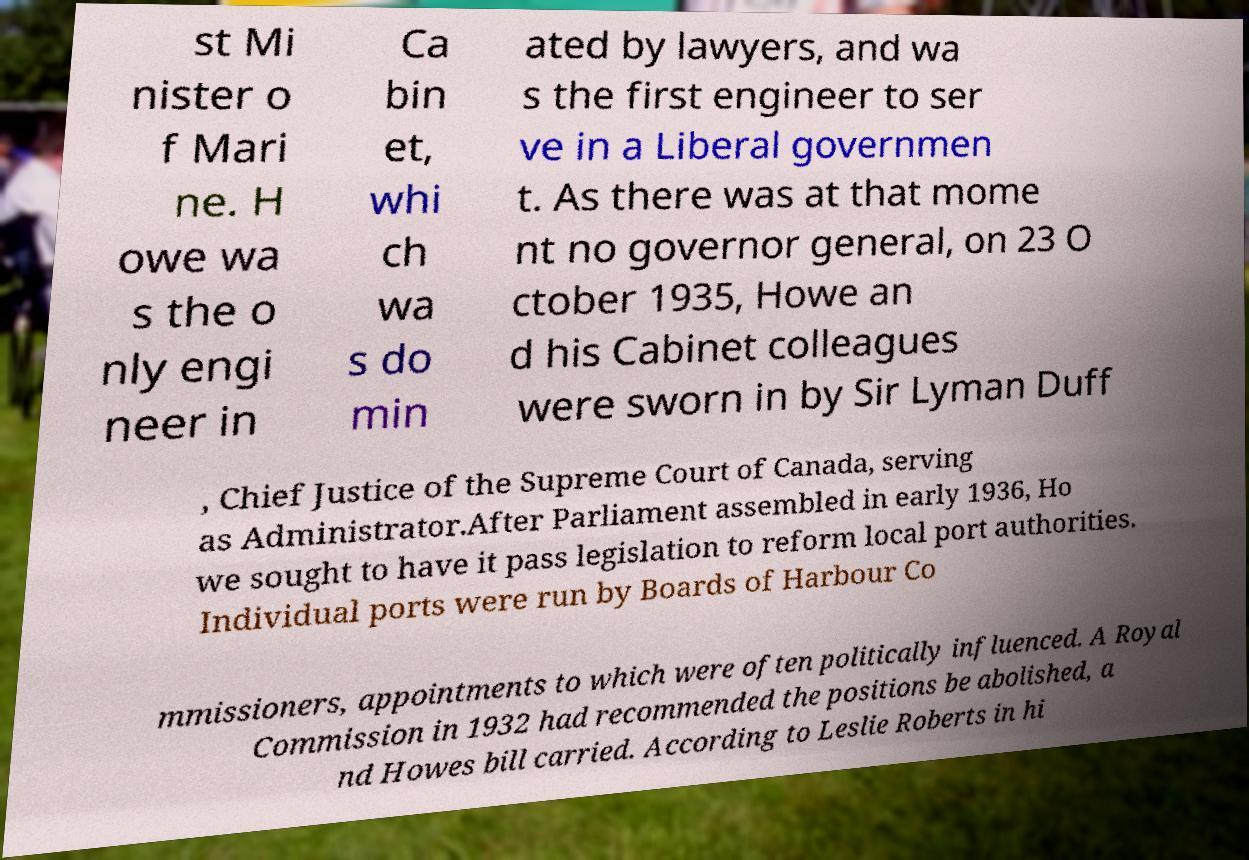Can you accurately transcribe the text from the provided image for me? st Mi nister o f Mari ne. H owe wa s the o nly engi neer in Ca bin et, whi ch wa s do min ated by lawyers, and wa s the first engineer to ser ve in a Liberal governmen t. As there was at that mome nt no governor general, on 23 O ctober 1935, Howe an d his Cabinet colleagues were sworn in by Sir Lyman Duff , Chief Justice of the Supreme Court of Canada, serving as Administrator.After Parliament assembled in early 1936, Ho we sought to have it pass legislation to reform local port authorities. Individual ports were run by Boards of Harbour Co mmissioners, appointments to which were often politically influenced. A Royal Commission in 1932 had recommended the positions be abolished, a nd Howes bill carried. According to Leslie Roberts in hi 